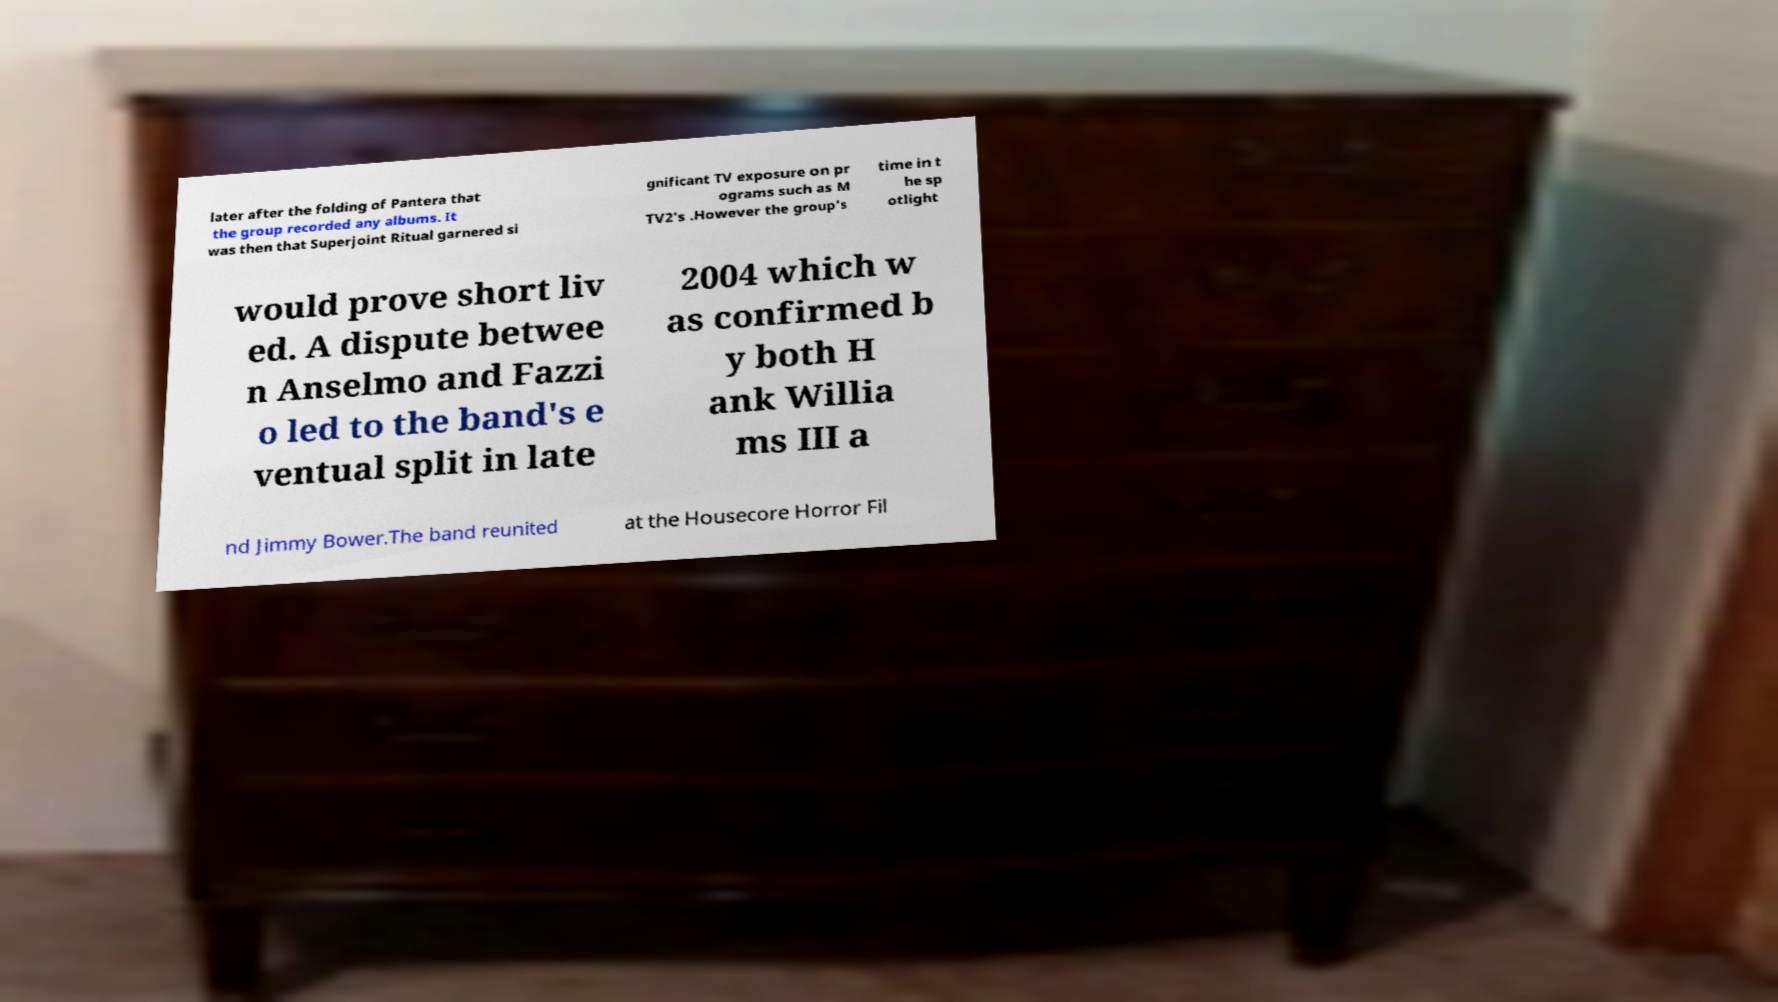Please identify and transcribe the text found in this image. later after the folding of Pantera that the group recorded any albums. It was then that Superjoint Ritual garnered si gnificant TV exposure on pr ograms such as M TV2's .However the group's time in t he sp otlight would prove short liv ed. A dispute betwee n Anselmo and Fazzi o led to the band's e ventual split in late 2004 which w as confirmed b y both H ank Willia ms III a nd Jimmy Bower.The band reunited at the Housecore Horror Fil 